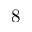Convert formula to latex. <formula><loc_0><loc_0><loc_500><loc_500>8</formula> 